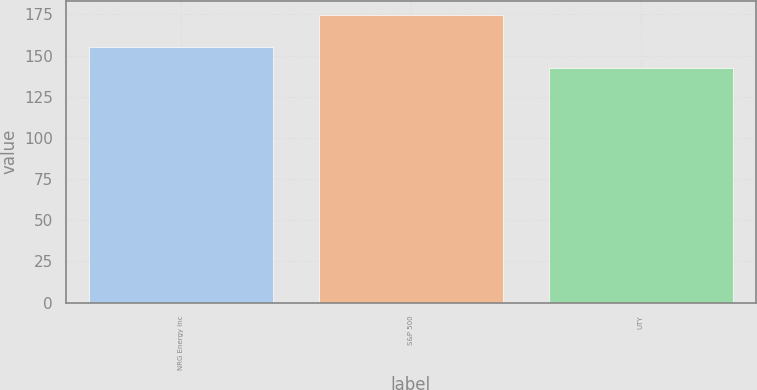Convert chart to OTSL. <chart><loc_0><loc_0><loc_500><loc_500><bar_chart><fcel>NRG Energy Inc<fcel>S&P 500<fcel>UTY<nl><fcel>155.29<fcel>174.6<fcel>142.29<nl></chart> 